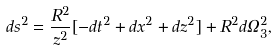<formula> <loc_0><loc_0><loc_500><loc_500>d s ^ { 2 } = \frac { R ^ { 2 } } { z ^ { 2 } } [ - d t ^ { 2 } + d x ^ { 2 } + d z ^ { 2 } ] + R ^ { 2 } d \Omega _ { 3 } ^ { 2 } ,</formula> 